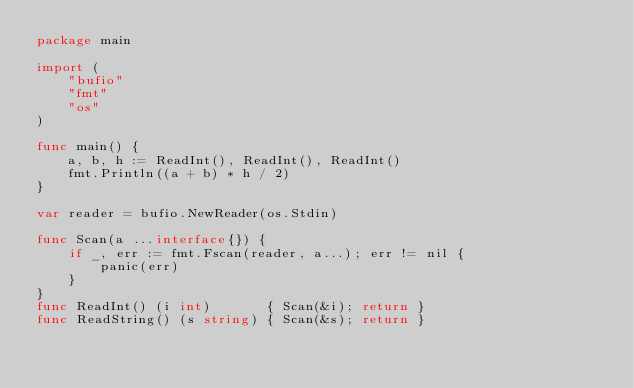<code> <loc_0><loc_0><loc_500><loc_500><_Go_>package main

import (
	"bufio"
	"fmt"
	"os"
)

func main() {
	a, b, h := ReadInt(), ReadInt(), ReadInt()
	fmt.Println((a + b) * h / 2)
}

var reader = bufio.NewReader(os.Stdin)

func Scan(a ...interface{}) {
	if _, err := fmt.Fscan(reader, a...); err != nil {
		panic(err)
	}
}
func ReadInt() (i int)       { Scan(&i); return }
func ReadString() (s string) { Scan(&s); return }
</code> 